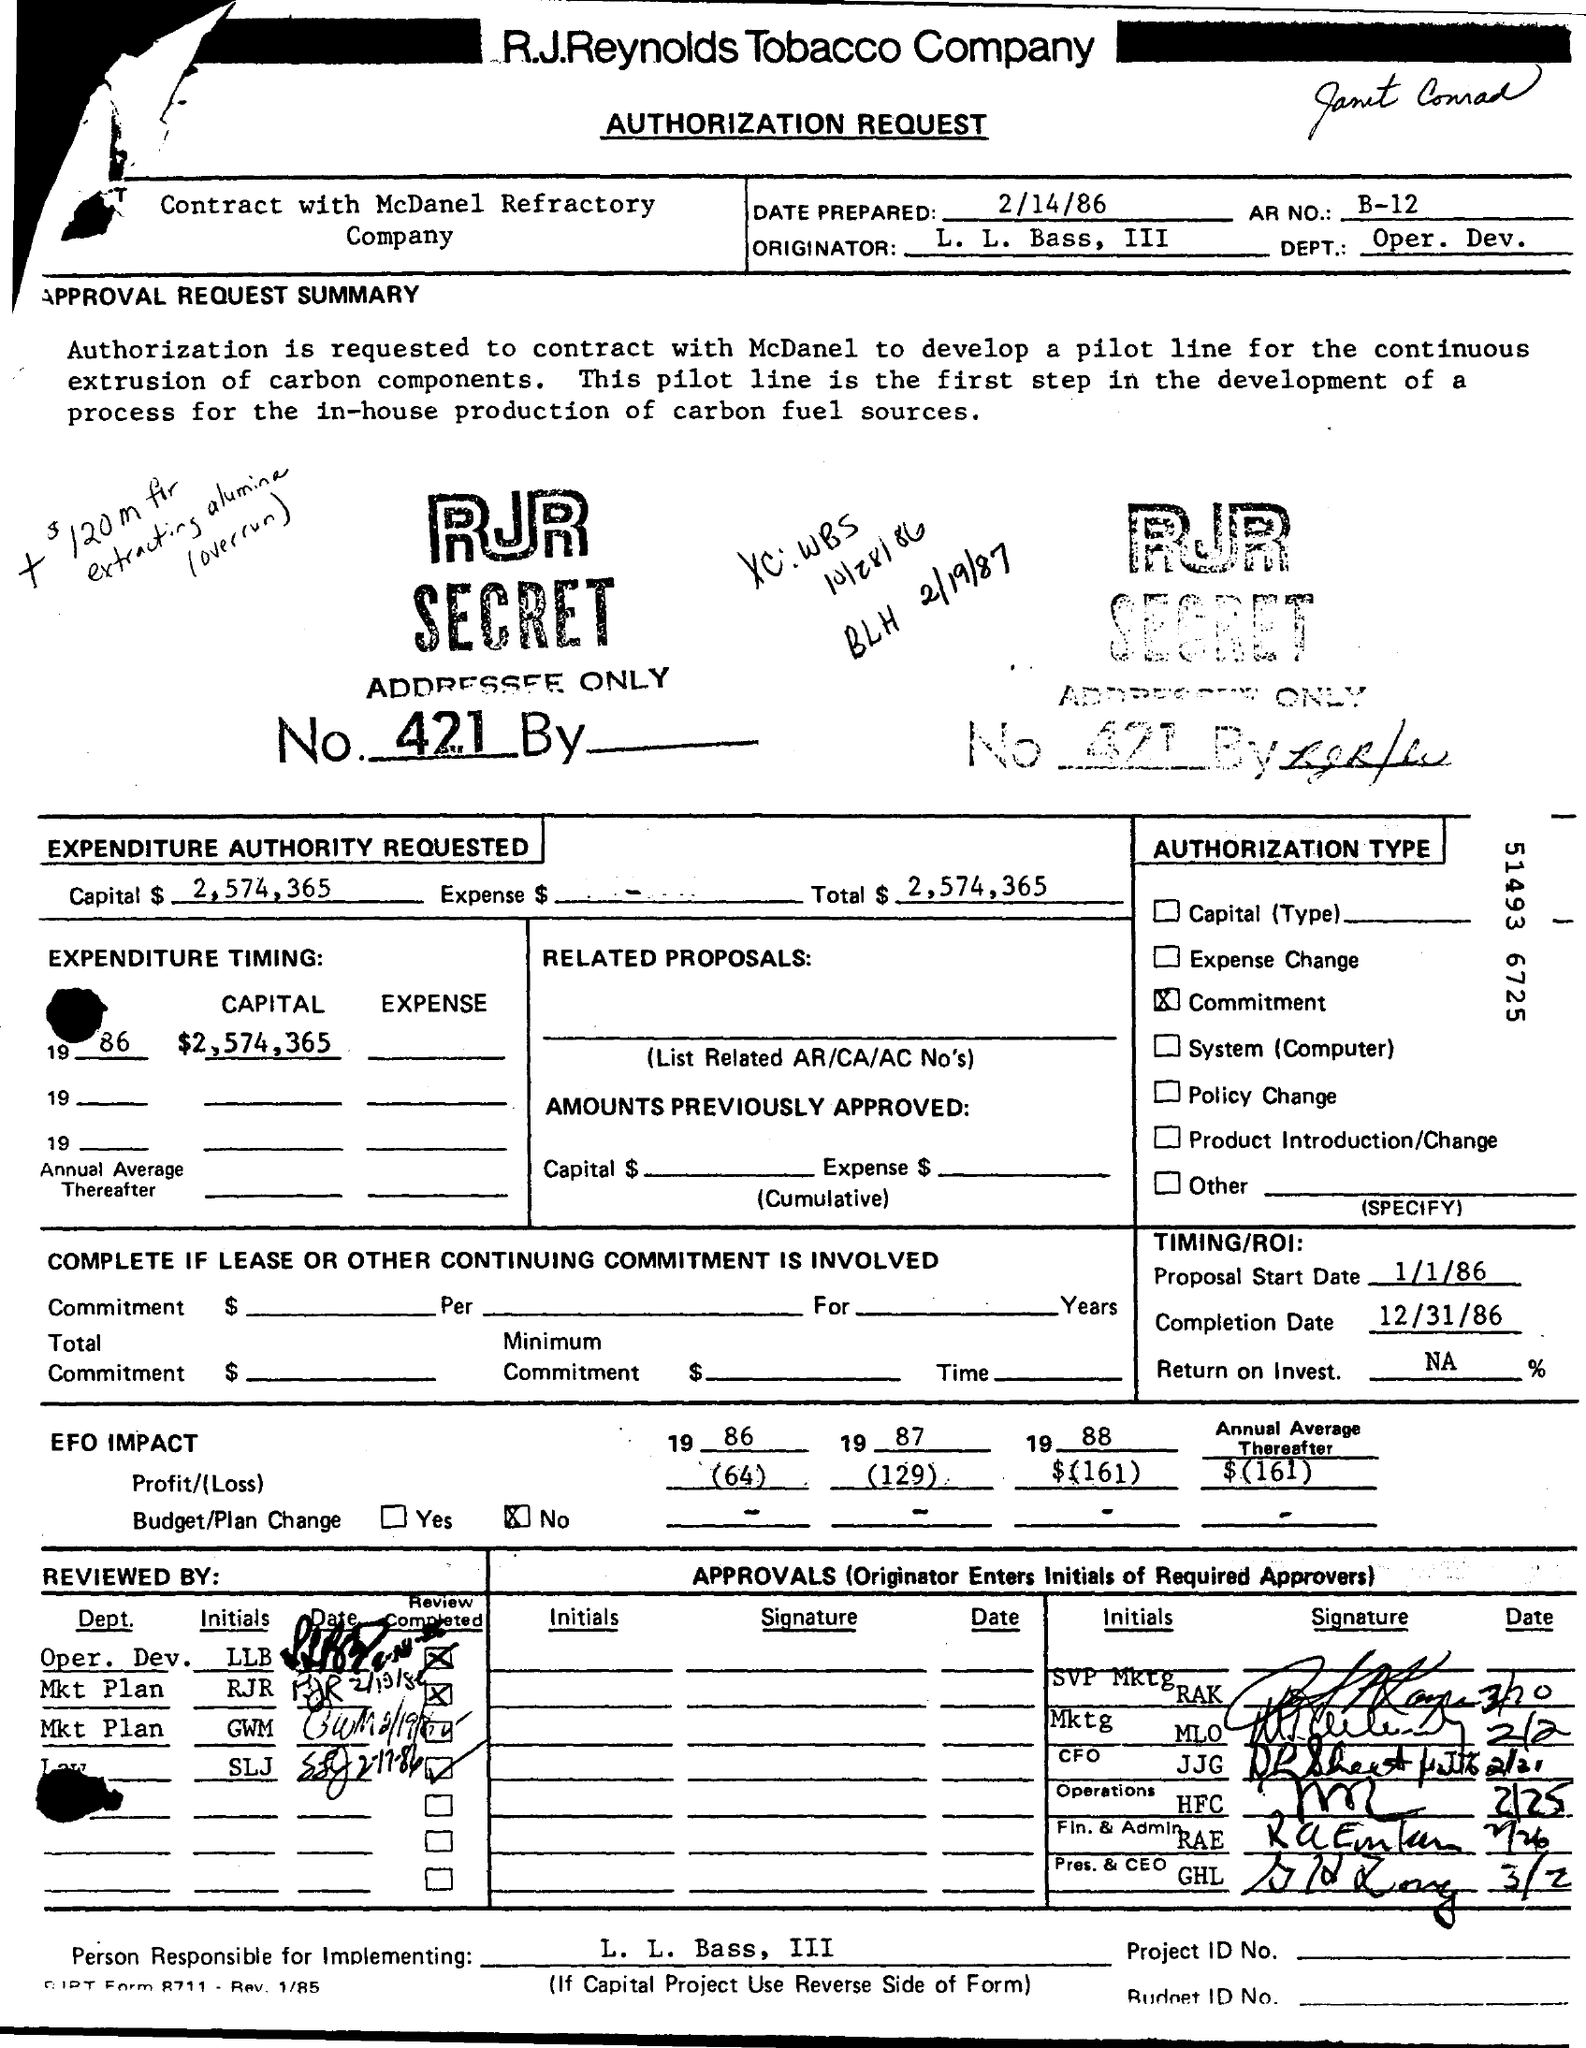What is the Completion Date? The completion date specified on the authorization request document is December 31, 1986. This date marks the planned conclusion of setting up a line for the continuous extrusion of components, a vital component of a project aimed at developing in-house carbon fuel source production. 